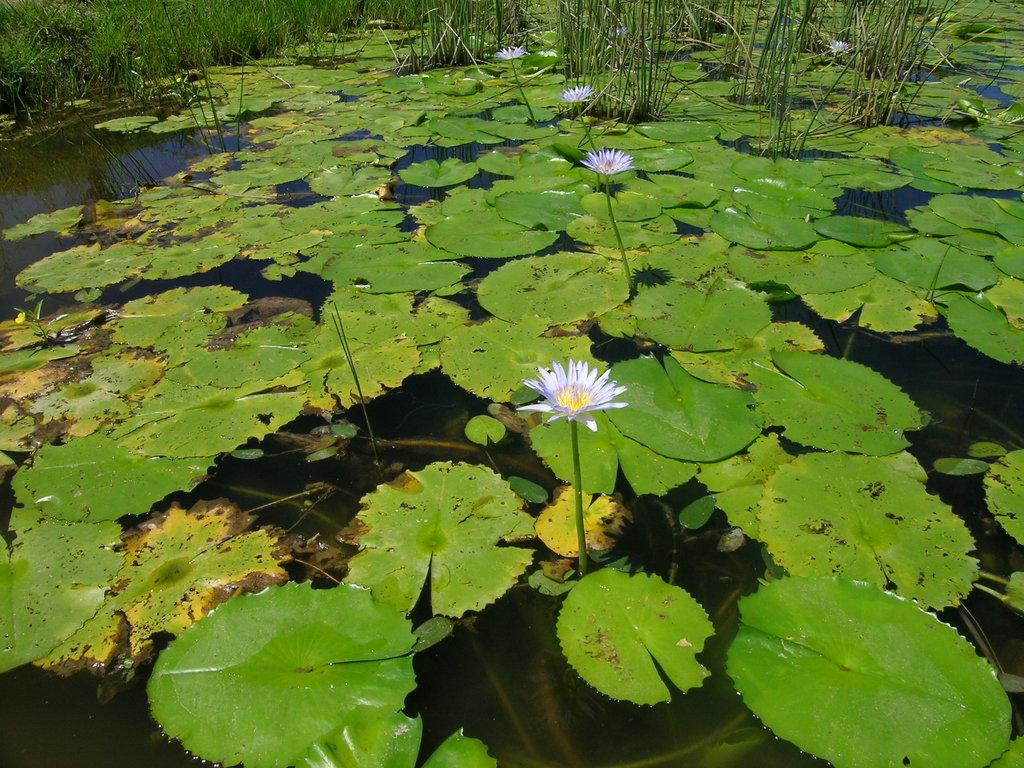What is the main subject of the image? The main subject of the image is plants with flowers in the water. What colors can be seen in the flowers? The flowers are in purple, white, and yellow colors. Are there any other plants visible in the image? Yes, there are more plants in the background of the image. How does the process of digestion affect the lead content in the plants? There is no mention of digestion or lead content in the image, as it features plants with flowers in the water. 